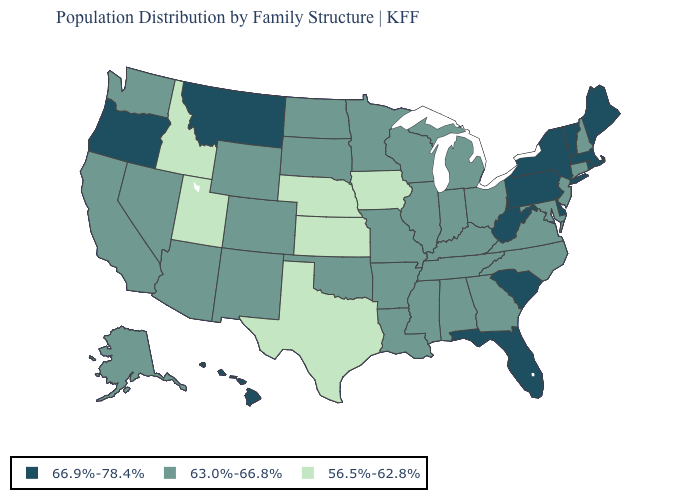Which states have the lowest value in the West?
Write a very short answer. Idaho, Utah. What is the highest value in the USA?
Concise answer only. 66.9%-78.4%. What is the value of Nebraska?
Answer briefly. 56.5%-62.8%. Does Oklahoma have a higher value than Iowa?
Answer briefly. Yes. Name the states that have a value in the range 66.9%-78.4%?
Answer briefly. Delaware, Florida, Hawaii, Maine, Massachusetts, Montana, New York, Oregon, Pennsylvania, Rhode Island, South Carolina, Vermont, West Virginia. Among the states that border Louisiana , does Texas have the lowest value?
Give a very brief answer. Yes. Which states have the lowest value in the USA?
Be succinct. Idaho, Iowa, Kansas, Nebraska, Texas, Utah. What is the value of Illinois?
Quick response, please. 63.0%-66.8%. Name the states that have a value in the range 56.5%-62.8%?
Short answer required. Idaho, Iowa, Kansas, Nebraska, Texas, Utah. What is the value of Alaska?
Give a very brief answer. 63.0%-66.8%. Name the states that have a value in the range 66.9%-78.4%?
Short answer required. Delaware, Florida, Hawaii, Maine, Massachusetts, Montana, New York, Oregon, Pennsylvania, Rhode Island, South Carolina, Vermont, West Virginia. What is the value of North Carolina?
Short answer required. 63.0%-66.8%. Name the states that have a value in the range 63.0%-66.8%?
Keep it brief. Alabama, Alaska, Arizona, Arkansas, California, Colorado, Connecticut, Georgia, Illinois, Indiana, Kentucky, Louisiana, Maryland, Michigan, Minnesota, Mississippi, Missouri, Nevada, New Hampshire, New Jersey, New Mexico, North Carolina, North Dakota, Ohio, Oklahoma, South Dakota, Tennessee, Virginia, Washington, Wisconsin, Wyoming. Name the states that have a value in the range 63.0%-66.8%?
Be succinct. Alabama, Alaska, Arizona, Arkansas, California, Colorado, Connecticut, Georgia, Illinois, Indiana, Kentucky, Louisiana, Maryland, Michigan, Minnesota, Mississippi, Missouri, Nevada, New Hampshire, New Jersey, New Mexico, North Carolina, North Dakota, Ohio, Oklahoma, South Dakota, Tennessee, Virginia, Washington, Wisconsin, Wyoming. Name the states that have a value in the range 56.5%-62.8%?
Be succinct. Idaho, Iowa, Kansas, Nebraska, Texas, Utah. 